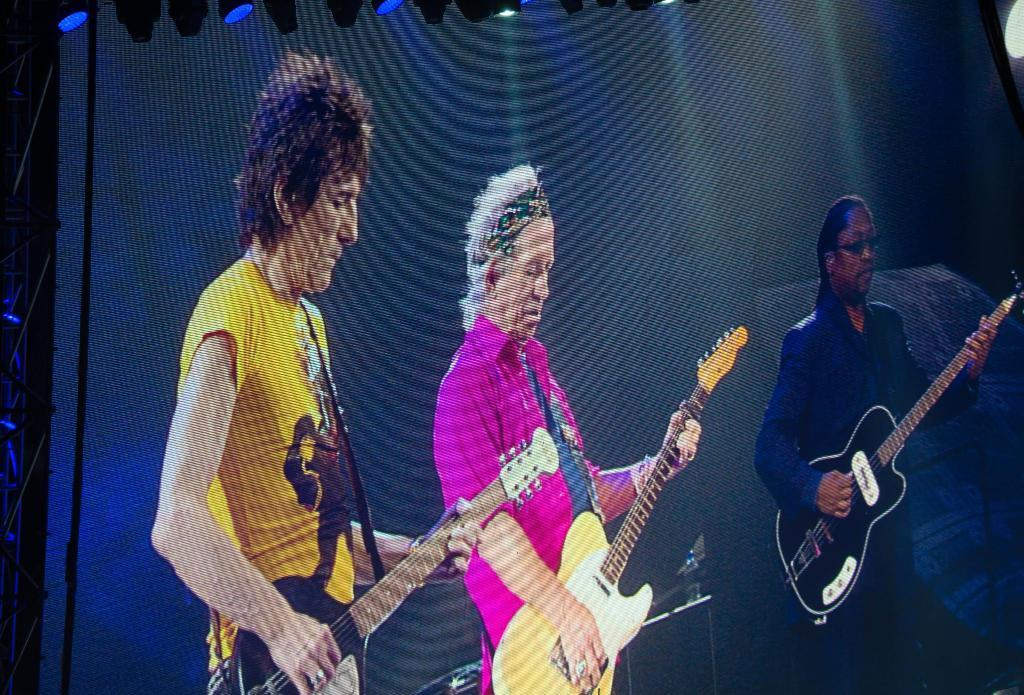How many people are in the image? There are three persons in the image. What are the persons doing in the image? Each person is holding a guitar and playing it. What can be seen in the background of the image? There are black curtains in the background of the image. What is visible above the scene? There are lights visible above the scene. How many babies are crawling on the floor in the image? There are no babies present in the image; it features three persons playing guitars. What type of connection is being made between the guitars and the lights? There is no mention of a connection between the guitars and the lights in the image. 